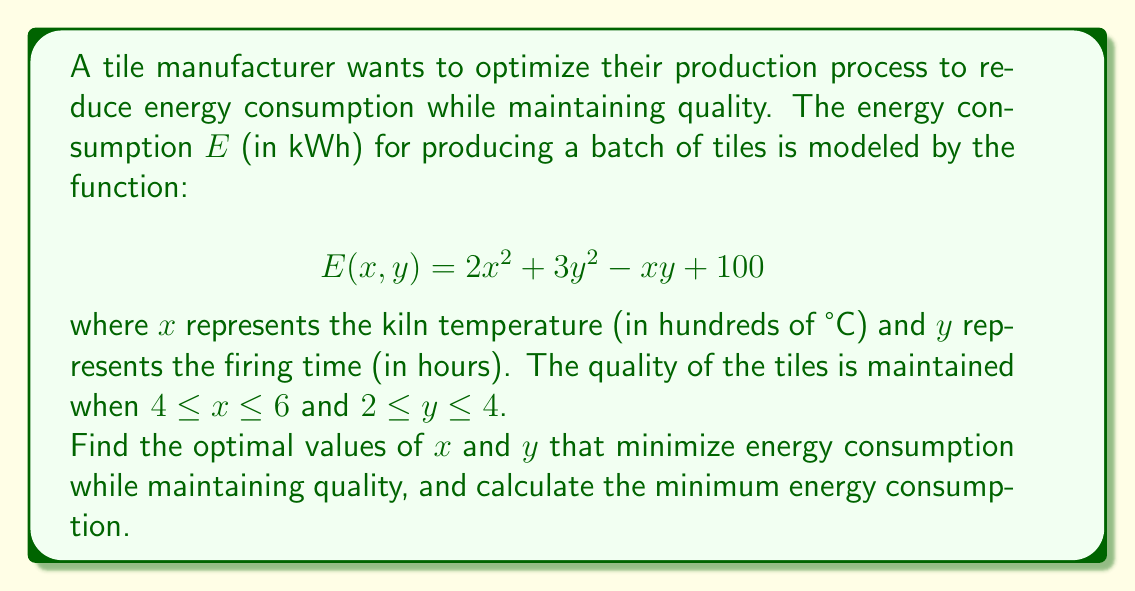Give your solution to this math problem. To solve this optimization problem, we'll follow these steps:

1) First, we need to find the critical points of the function $E(x, y)$ by taking partial derivatives and setting them to zero:

   $$\frac{\partial E}{\partial x} = 4x - y = 0$$
   $$\frac{\partial E}{\partial y} = 6y - x = 0$$

2) Solving this system of equations:
   From the second equation: $x = 6y$
   Substituting into the first equation:
   $4(6y) - y = 0$
   $24y - y = 0$
   $23y = 0$
   $y = 0$
   And consequently, $x = 0$

3) However, $(0, 0)$ is outside our constrained region. Therefore, the minimum must occur on the boundary of our region.

4) We need to check the edges of our constrained region:
   - When $x = 4$: $E(4, y) = 32 + 3y^2 - 4y + 100$
   - When $x = 6$: $E(6, y) = 72 + 3y^2 - 6y + 100$
   - When $y = 2$: $E(x, 2) = 2x^2 + 12 - 2x + 100$
   - When $y = 4$: $E(x, 4) = 2x^2 + 48 - 4x + 100$

5) For each of these, we can find the minimum within our constraints:
   - For $E(4, y)$, minimum occurs at $y = 2$, giving $E(4, 2) = 140$
   - For $E(6, y)$, minimum occurs at $y = 2$, giving $E(6, 2) = 180$
   - For $E(x, 2)$, minimum occurs at $x = 4$, giving $E(4, 2) = 140$
   - For $E(x, 4)$, minimum occurs at $x = 4$, giving $E(4, 4) = 164$

6) The overall minimum is 140 kWh, occurring at $(x, y) = (4, 2)$.

Therefore, the optimal kiln temperature is 400°C and the optimal firing time is 2 hours.
Answer: $(x, y) = (4, 2)$; $E_{min} = 140$ kWh 